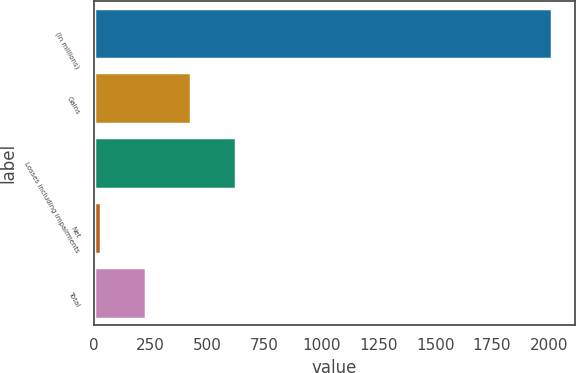Convert chart. <chart><loc_0><loc_0><loc_500><loc_500><bar_chart><fcel>(In millions)<fcel>Gains<fcel>Losses including impairments<fcel>Net<fcel>Total<nl><fcel>2012<fcel>429.6<fcel>627.4<fcel>34<fcel>231.8<nl></chart> 